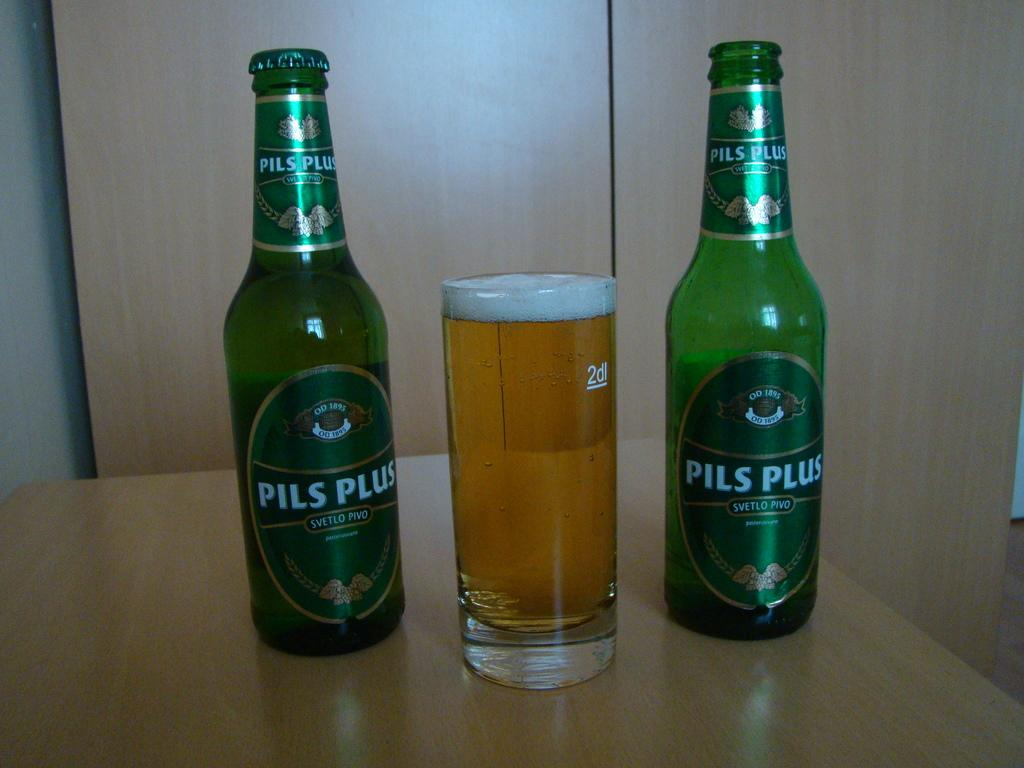<image>
Give a short and clear explanation of the subsequent image. An open and un-opened bottle of Pils Plus beer with green labels with a full drinking glass in the center. 